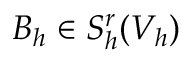<formula> <loc_0><loc_0><loc_500><loc_500>B _ { h } \in S _ { h } ^ { r } ( V _ { h } )</formula> 